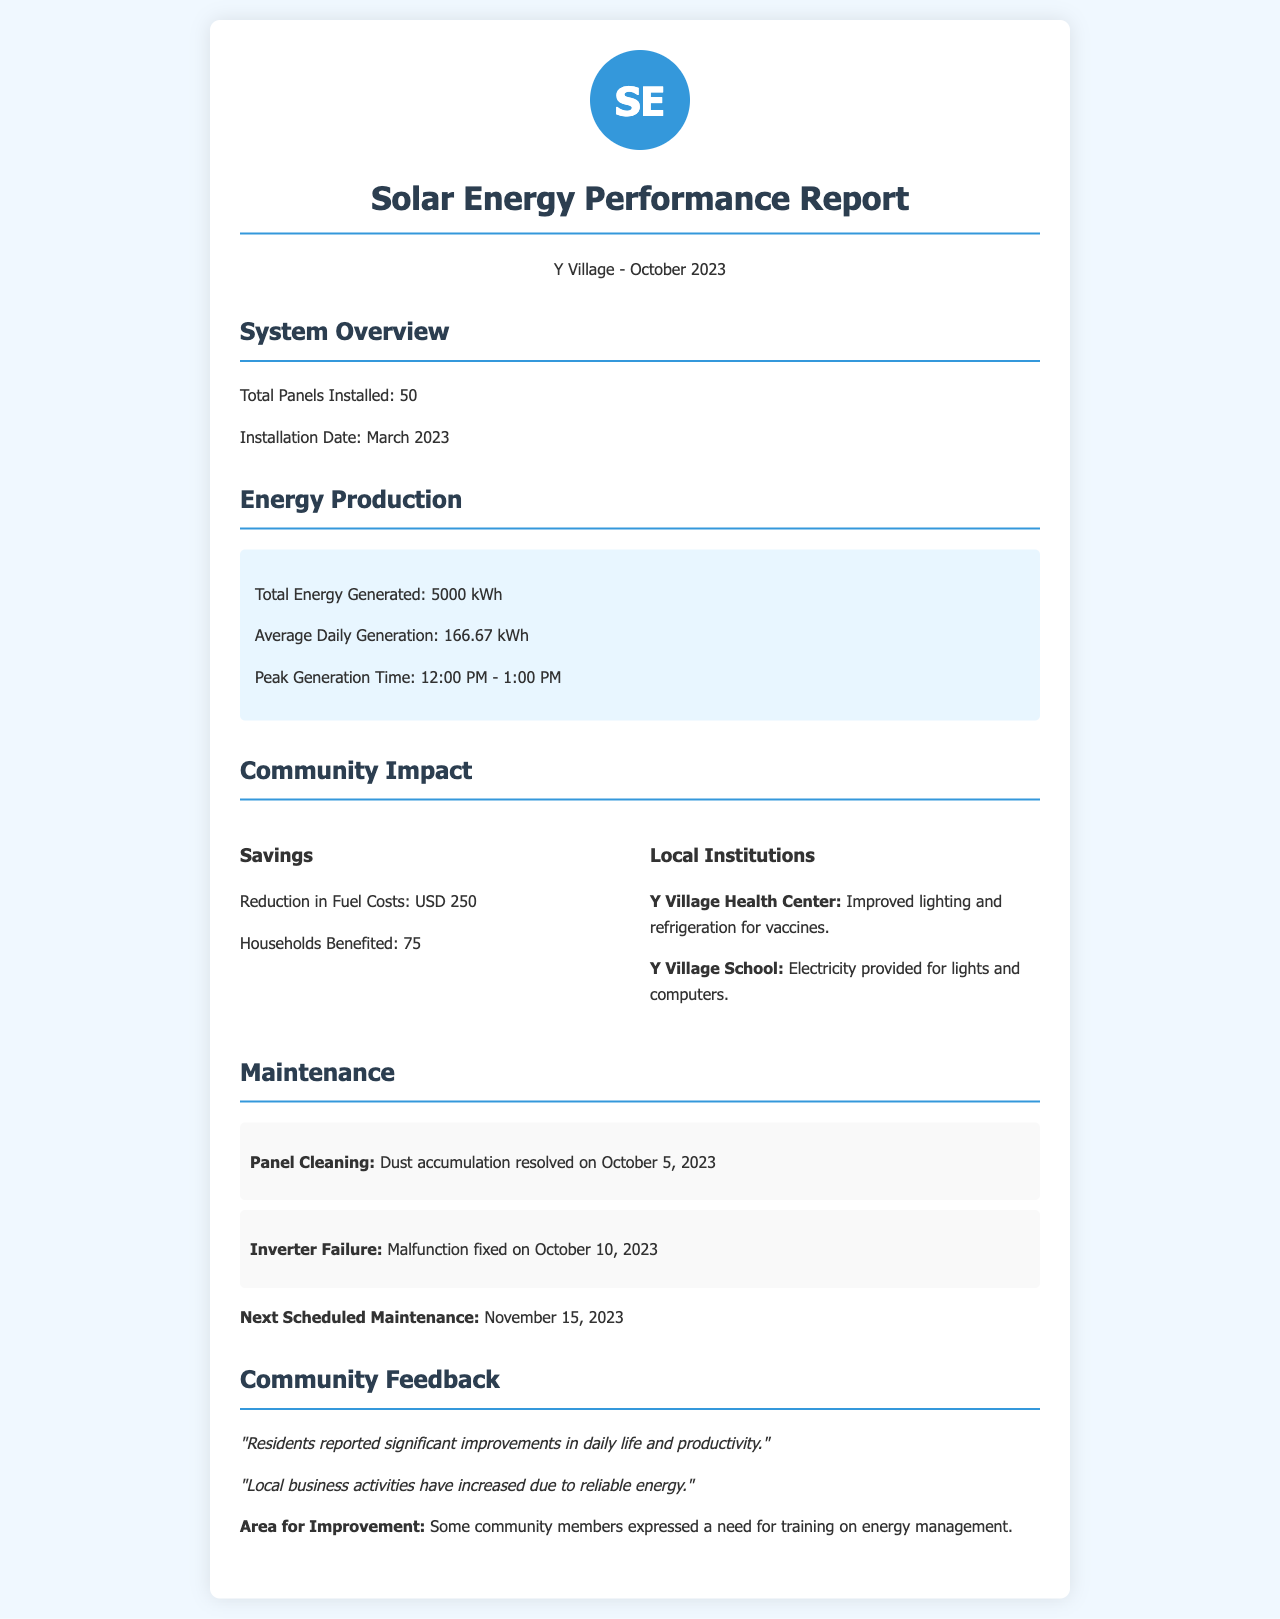What is the total number of panels installed? The total number of panels installed is provided in the system overview section of the document.
Answer: 50 What was the total energy generated in October 2023? The total energy generated is mentioned in the energy production section of the report.
Answer: 5000 kWh When was the inverter malfunction fixed? The maintenance section states the date when the inverter failure was resolved.
Answer: October 10, 2023 How much was the reduction in fuel costs? The savings section includes the amount of reduction in fuel costs for the community.
Answer: USD 250 What is the average daily energy generation? The average daily generation appears in the energy production part of the report.
Answer: 166.67 kWh Which local institution received improved lighting and refrigeration? The community impact section specifies which institution benefited from improved energy solutions.
Answer: Y Village Health Center What is the date of the next scheduled maintenance? The next scheduled maintenance date is found in the maintenance section of the document.
Answer: November 15, 2023 What feedback did residents give regarding community improvements? Community feedback provides insight into the residents' views on improvements due to the energy solution.
Answer: "Residents reported significant improvements in daily life and productivity." 